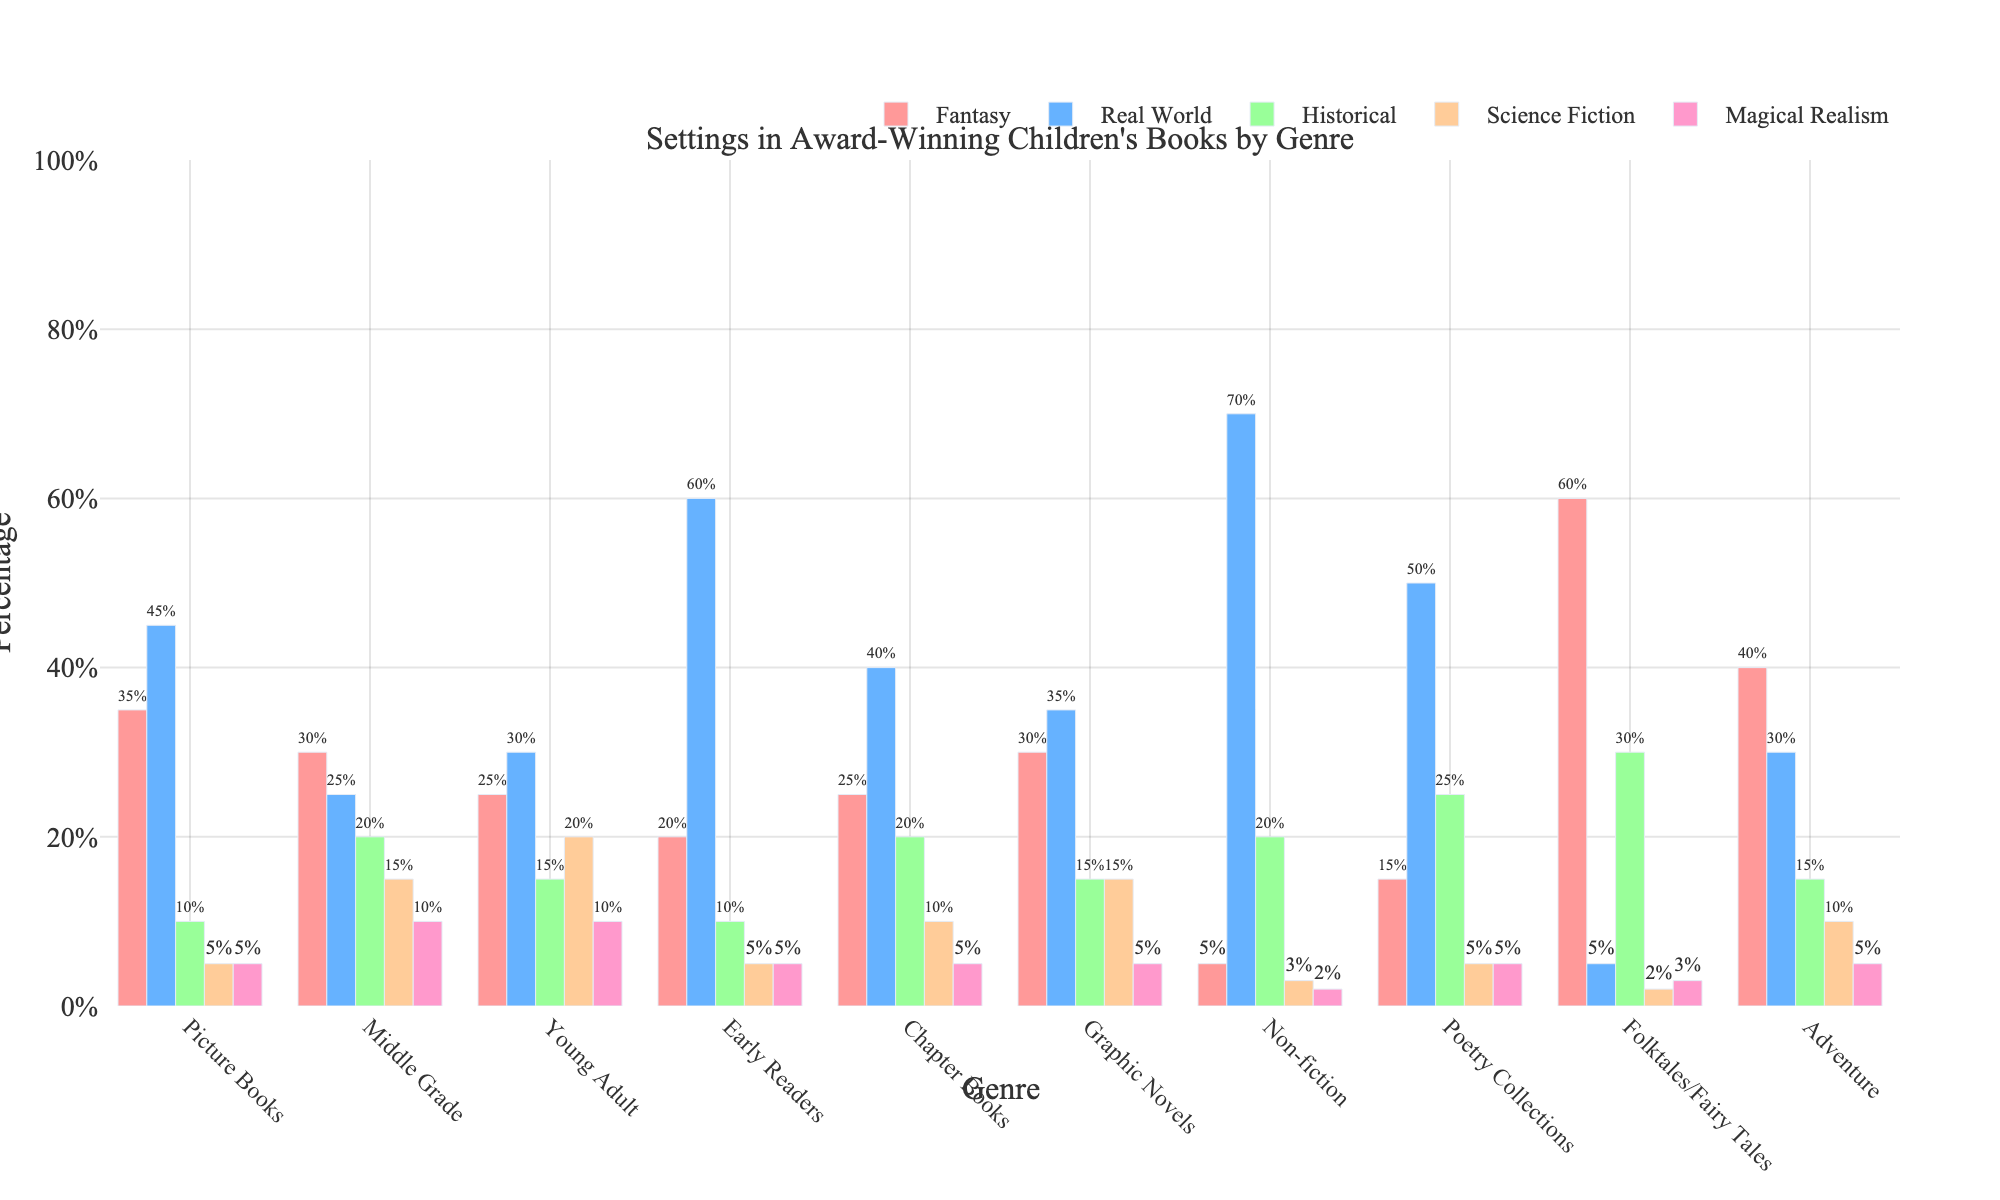Which genre has the highest percentage of Real World settings? Look at the heights of the bars corresponding to the Real World setting. The Non-fiction genre has the highest bar, indicating the highest percentage.
Answer: Non-fiction Which genre has the lowest percentage of Fantasy settings? Look at the heights of the bars corresponding to the Fantasy setting. The Non-fiction genre has the smallest bar.
Answer: Non-fiction How many genres have more than 50% of their settings in the Real World? Look at the bars corresponding to the Real World setting and count the genres where the bars extend beyond 50%. Picture Books, Early Readers, Non-fiction, and Poetry Collections all have more than 50%.
Answer: 4 Which genre has an equal percentage of Fantasy and Magical Realism settings? Look for genres where the heights of bars for Fantasy and Magical Realism are the same. None of the genres have these settings equal.
Answer: None Compare the percentages of Historical settings in Middle Grade and Young Adult genres. Which one is higher and by how much? Look at the bars for Historical settings in both Middle Grade and Young Adult genres. Middle Grade has 20%, and Young Adult has 15%, so Middle Grade is higher by 5%.
Answer: Middle Grade by 5% Which setting is more common in Adventure books: Science Fiction or Historical? Look at the bars for Science Fiction and Historical settings in the Adventure genre. Historical has a higher bar.
Answer: Historical What is the average percentage of Fantasy settings across all genres? Add up the percentages of Fantasy settings for all genres and then divide by the number of genres. (35+30+25+20+25+30+5+15+60+40)/10 = 28.5
Answer: 28.5% Which two genres have the closest percentage of Science Fiction settings? Compare the Science Fiction bars for all genres to find the two with the most similar heights. Middle Grade (15%) and Graphic Novels (15%) are the closest with identical values.
Answer: Middle Grade and Graphic Novels In which genres does the percentage of Magical Realism settings equal the percentage of Science Fiction settings? Look for bars of the same height for both Magical Realism and Science Fiction settings within a genre. Middle Grade (10%) and Young Adult (10%) fit this description.
Answer: Middle Grade and Young Adult 